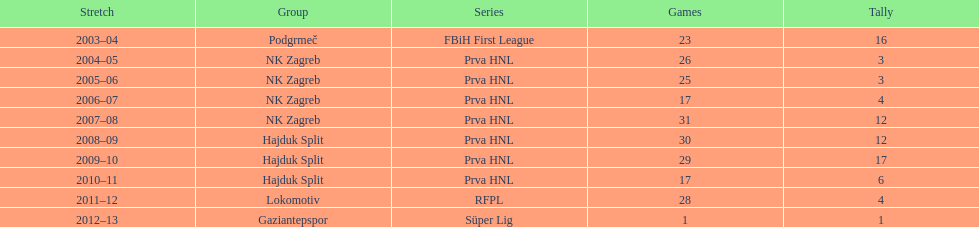The team with the most goals Hajduk Split. 